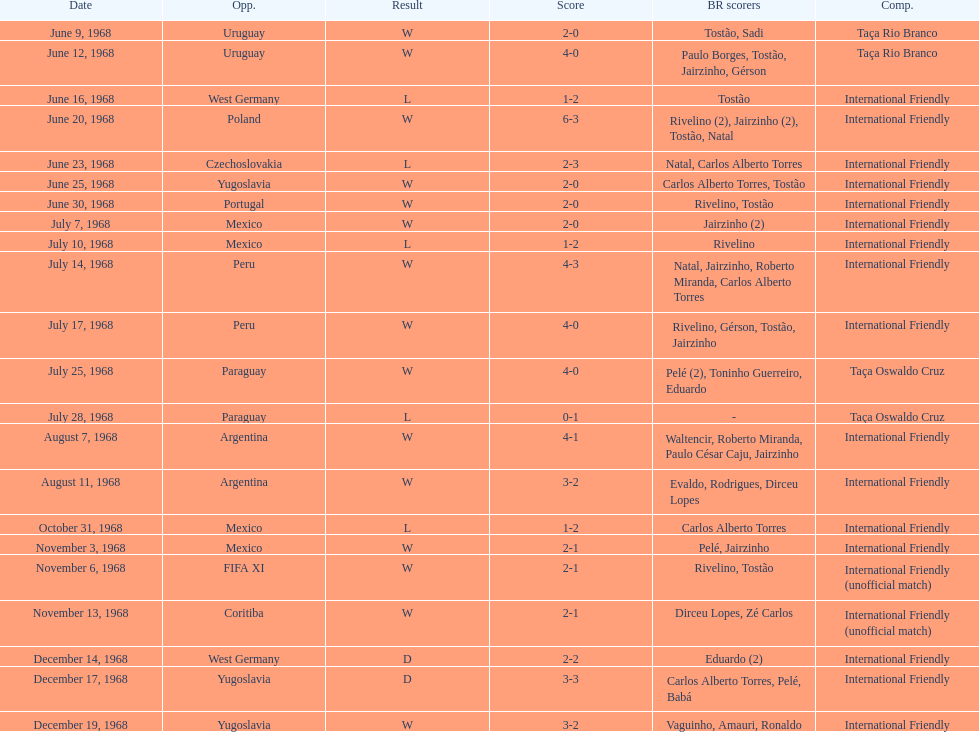What's the total number of ties? 2. 